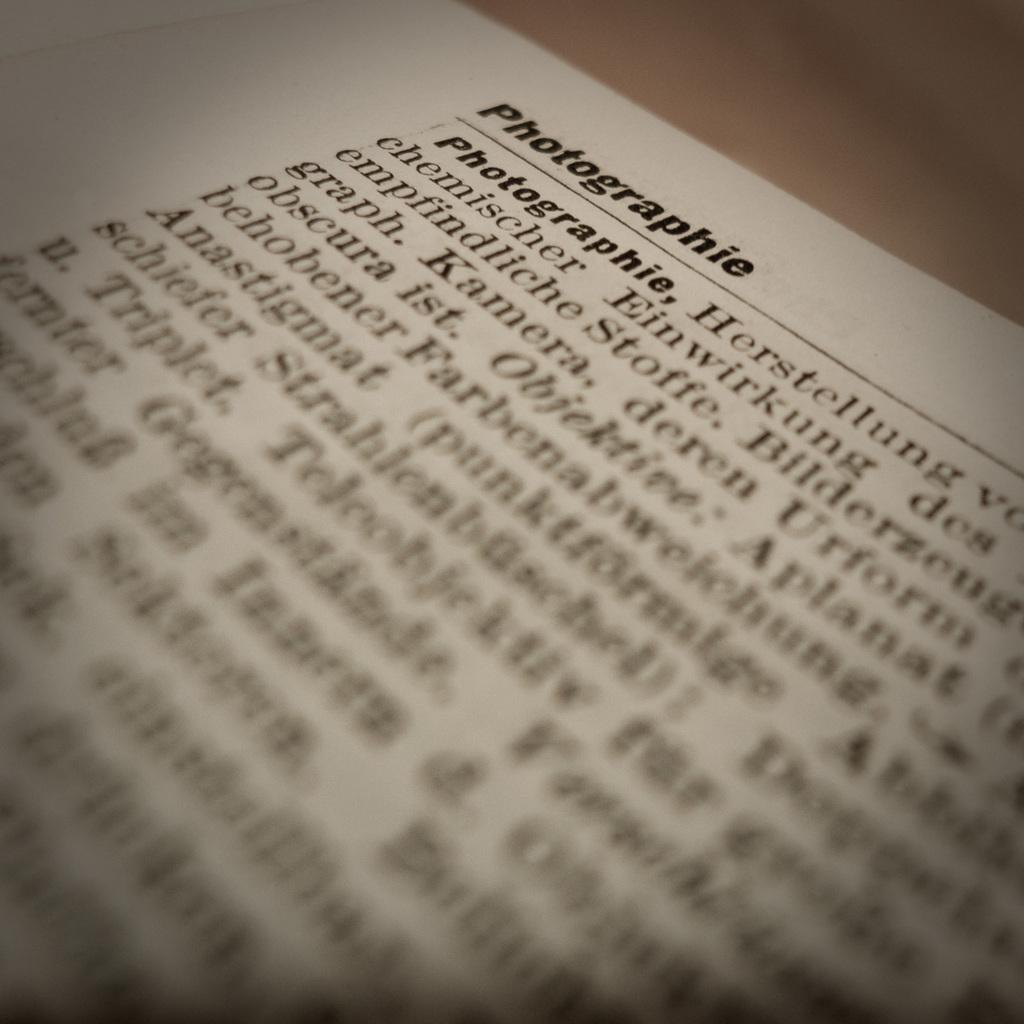Provide a one-sentence caption for the provided image. A piece of paper has information about Photographie written on it in German. 